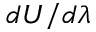Convert formula to latex. <formula><loc_0><loc_0><loc_500><loc_500>d U / d \lambda</formula> 